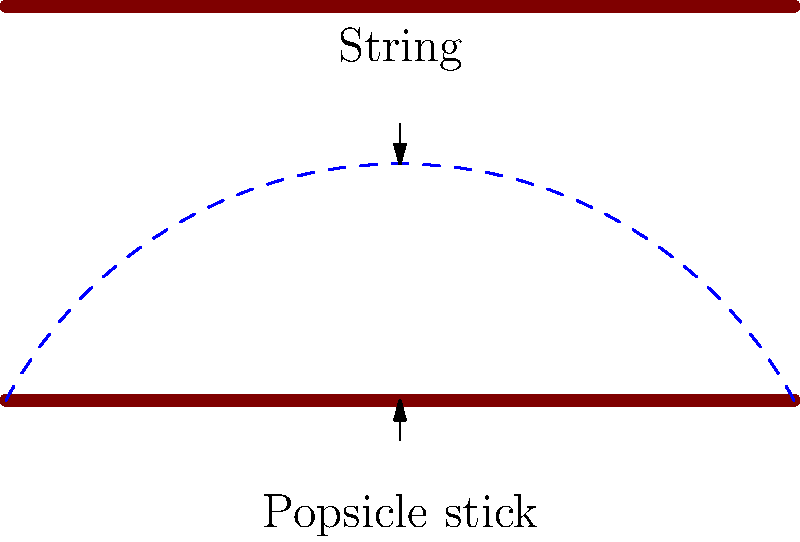As a child psychologist creating educational content for a children's TV show about simple engineering concepts, how would you explain the role of tension in a popsicle stick bridge to young viewers? 1. Start by explaining that tension is like a pulling force, similar to when we stretch a rubber band.

2. In the popsicle stick bridge, the string experiences tension as it holds the weight of the bridge and any objects placed on it.

3. Describe how the string pulls on both popsicle sticks, keeping them in place and preventing the bridge from collapsing.

4. Use a simple analogy: compare the string to a tightrope walker's rope, which needs to be tight (in tension) to support the walker.

5. Explain that the popsicle sticks work together with the string. The sticks provide a flat surface to walk on, while the string holds everything together.

6. Emphasize that the tension in the string is what allows the bridge to support weight without breaking.

7. Encourage children to experiment by gently pressing down on the middle of the bridge to feel how the tension in the string increases.

8. Conclude by highlighting how understanding tension can help children build stronger bridges and other structures in their playtime engineering projects.
Answer: Tension in the string holds the popsicle sticks together and supports weight, like a tightrope supporting a walker. 